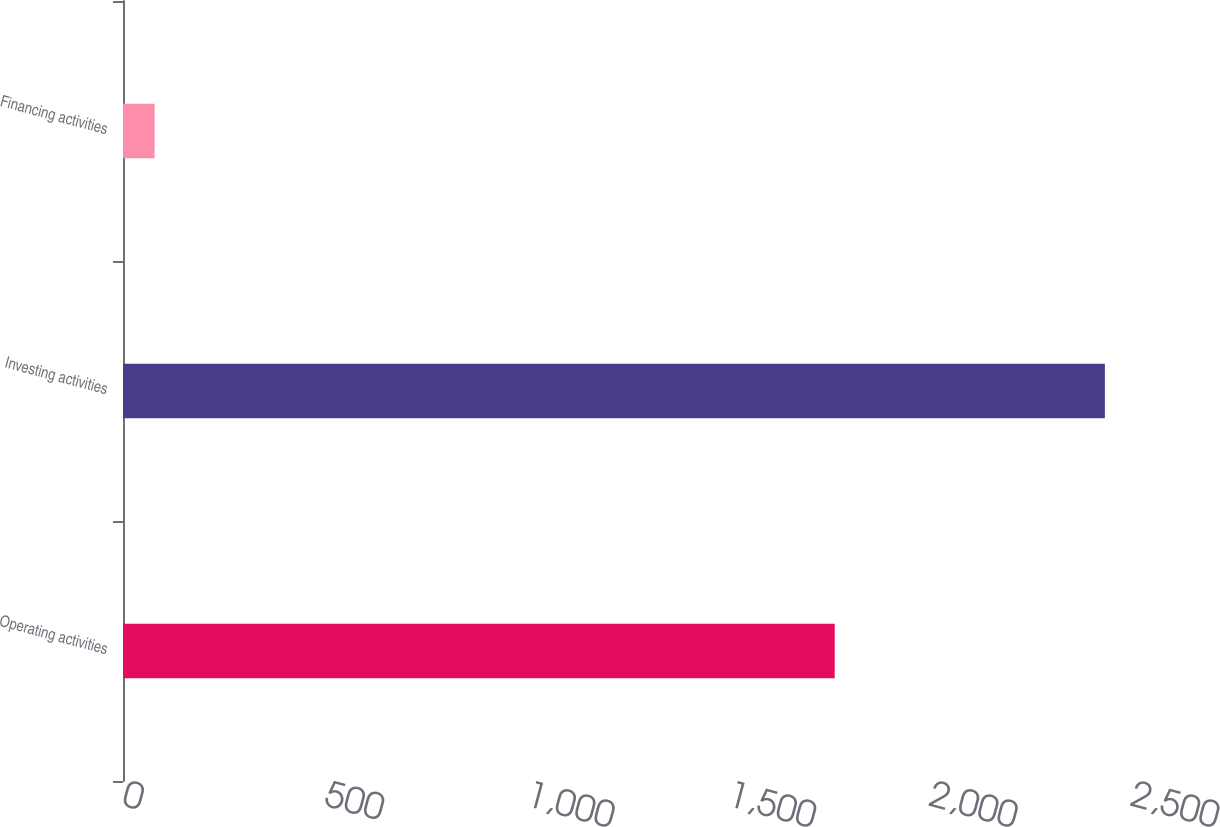Convert chart to OTSL. <chart><loc_0><loc_0><loc_500><loc_500><bar_chart><fcel>Operating activities<fcel>Investing activities<fcel>Financing activities<nl><fcel>1765.1<fcel>2435.2<fcel>78.4<nl></chart> 